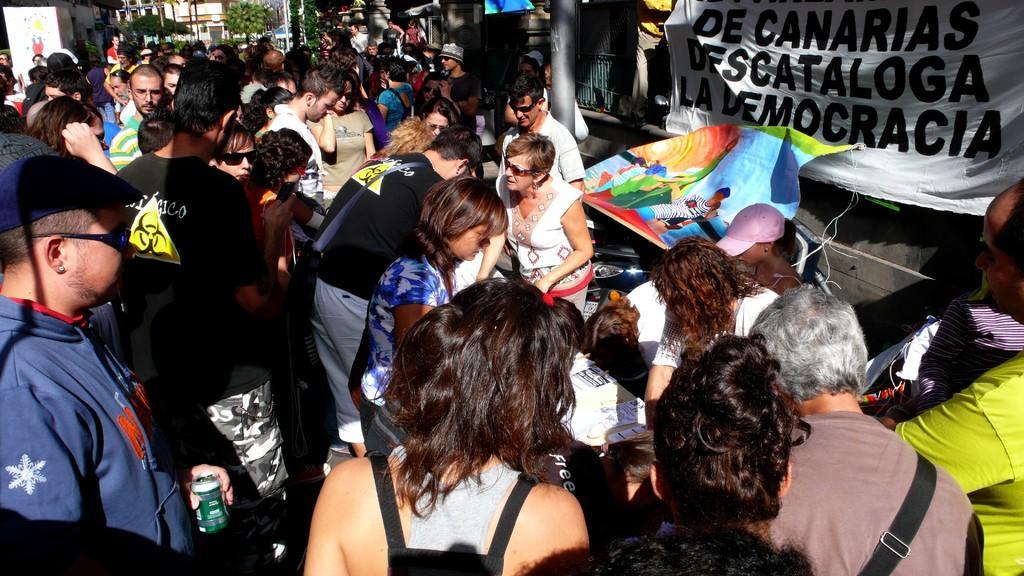Please provide a concise description of this image. This picture is clicked outside. On the left we can see the group of persons. On the right we can see the banners on which we can see the text and the pictures of some objects. In the background we can see the plants and the poles and some buildings. 